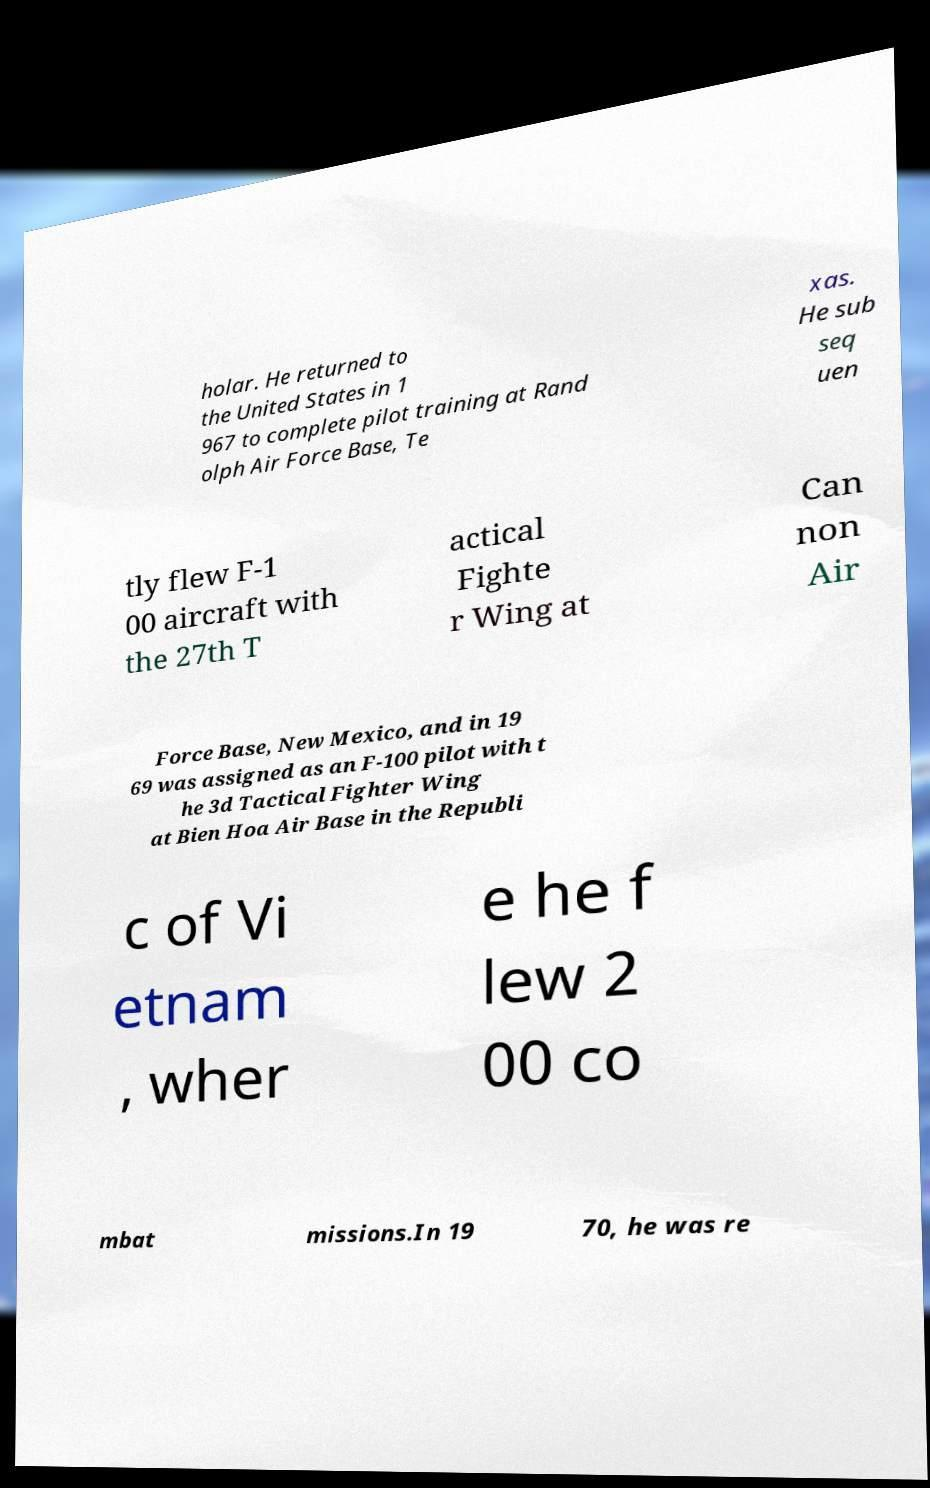Can you read and provide the text displayed in the image?This photo seems to have some interesting text. Can you extract and type it out for me? holar. He returned to the United States in 1 967 to complete pilot training at Rand olph Air Force Base, Te xas. He sub seq uen tly flew F-1 00 aircraft with the 27th T actical Fighte r Wing at Can non Air Force Base, New Mexico, and in 19 69 was assigned as an F-100 pilot with t he 3d Tactical Fighter Wing at Bien Hoa Air Base in the Republi c of Vi etnam , wher e he f lew 2 00 co mbat missions.In 19 70, he was re 